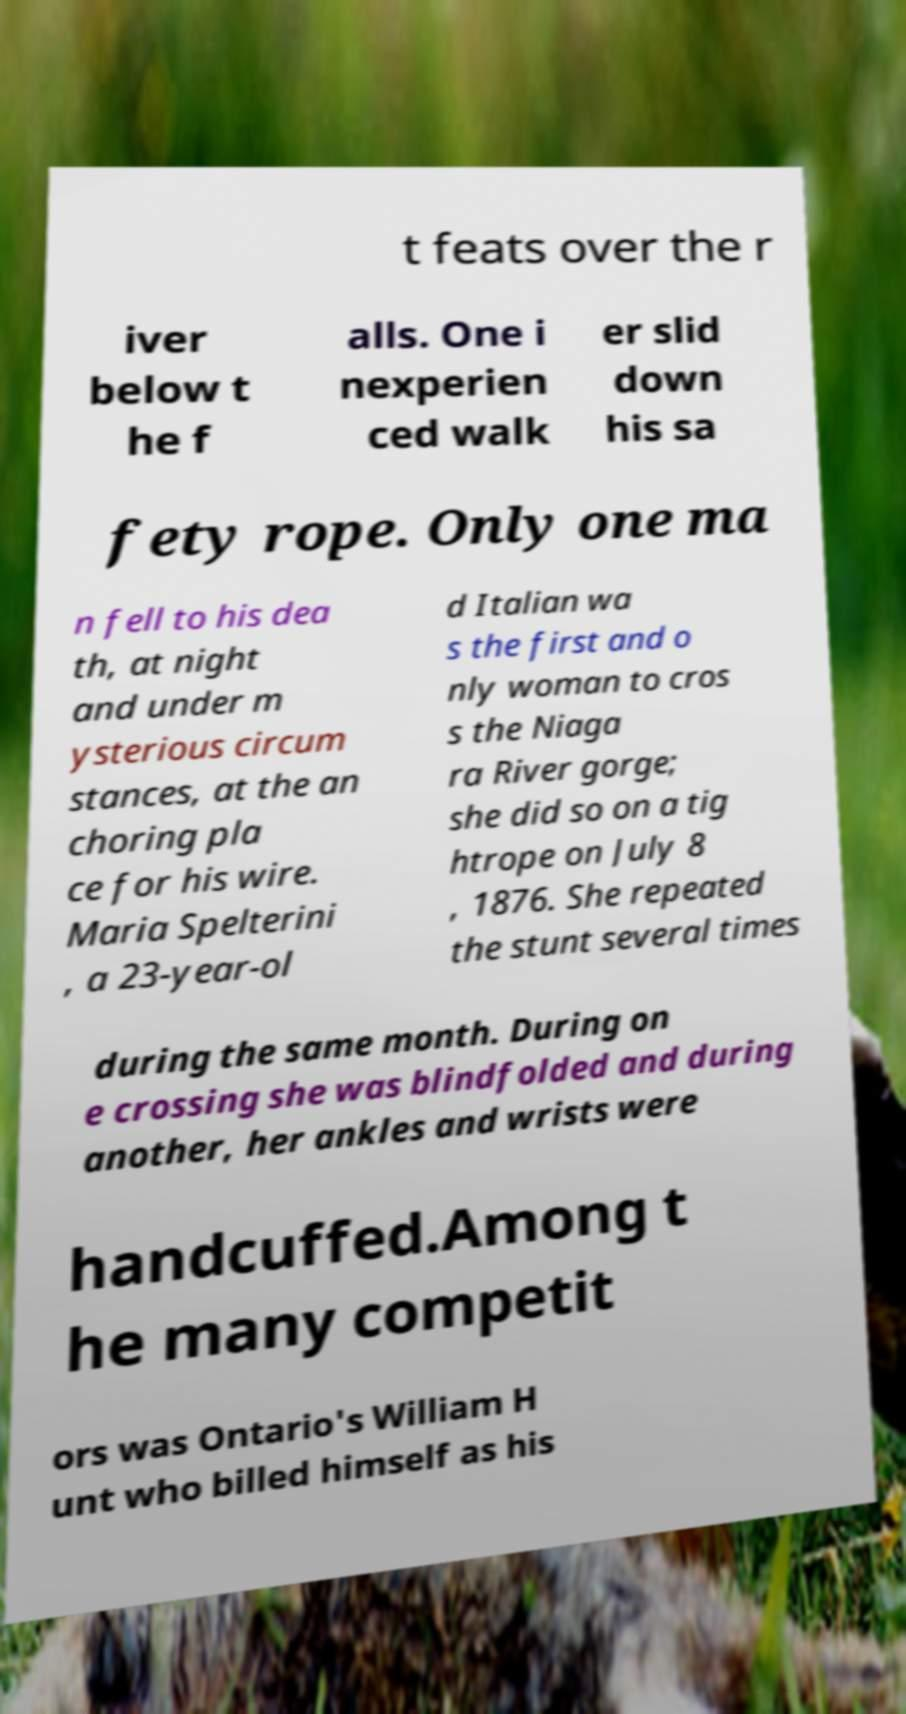Could you assist in decoding the text presented in this image and type it out clearly? t feats over the r iver below t he f alls. One i nexperien ced walk er slid down his sa fety rope. Only one ma n fell to his dea th, at night and under m ysterious circum stances, at the an choring pla ce for his wire. Maria Spelterini , a 23-year-ol d Italian wa s the first and o nly woman to cros s the Niaga ra River gorge; she did so on a tig htrope on July 8 , 1876. She repeated the stunt several times during the same month. During on e crossing she was blindfolded and during another, her ankles and wrists were handcuffed.Among t he many competit ors was Ontario's William H unt who billed himself as his 